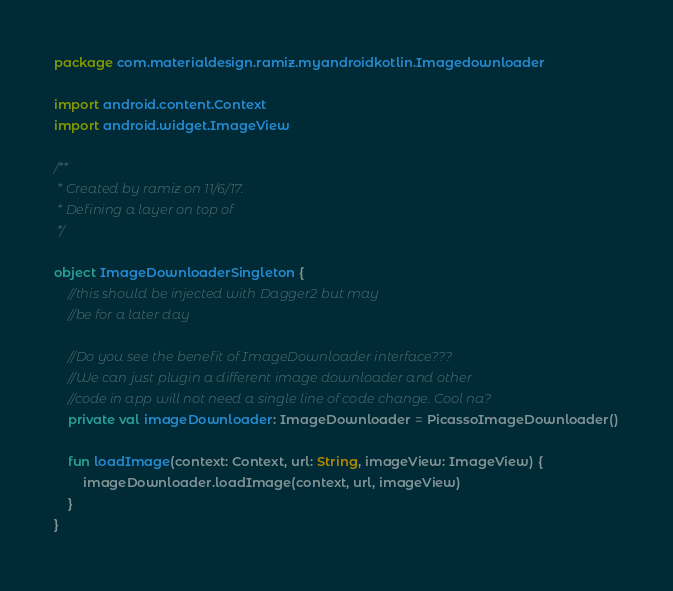Convert code to text. <code><loc_0><loc_0><loc_500><loc_500><_Kotlin_>package com.materialdesign.ramiz.myandroidkotlin.Imagedownloader

import android.content.Context
import android.widget.ImageView

/**
 * Created by ramiz on 11/6/17.
 * Defining a layer on top of
 */

object ImageDownloaderSingleton {
    //this should be injected with Dagger2 but may
    //be for a later day

    //Do you see the benefit of ImageDownloader interface???
    //We can just plugin a different image downloader and other
    //code in app will not need a single line of code change. Cool na?
    private val imageDownloader: ImageDownloader = PicassoImageDownloader()

    fun loadImage(context: Context, url: String, imageView: ImageView) {
        imageDownloader.loadImage(context, url, imageView)
    }
}</code> 